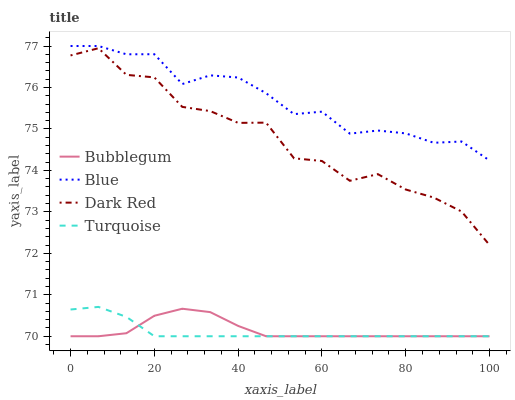Does Turquoise have the minimum area under the curve?
Answer yes or no. Yes. Does Blue have the maximum area under the curve?
Answer yes or no. Yes. Does Dark Red have the minimum area under the curve?
Answer yes or no. No. Does Dark Red have the maximum area under the curve?
Answer yes or no. No. Is Turquoise the smoothest?
Answer yes or no. Yes. Is Dark Red the roughest?
Answer yes or no. Yes. Is Dark Red the smoothest?
Answer yes or no. No. Is Turquoise the roughest?
Answer yes or no. No. Does Turquoise have the lowest value?
Answer yes or no. Yes. Does Dark Red have the lowest value?
Answer yes or no. No. Does Blue have the highest value?
Answer yes or no. Yes. Does Dark Red have the highest value?
Answer yes or no. No. Is Turquoise less than Blue?
Answer yes or no. Yes. Is Blue greater than Turquoise?
Answer yes or no. Yes. Does Bubblegum intersect Turquoise?
Answer yes or no. Yes. Is Bubblegum less than Turquoise?
Answer yes or no. No. Is Bubblegum greater than Turquoise?
Answer yes or no. No. Does Turquoise intersect Blue?
Answer yes or no. No. 